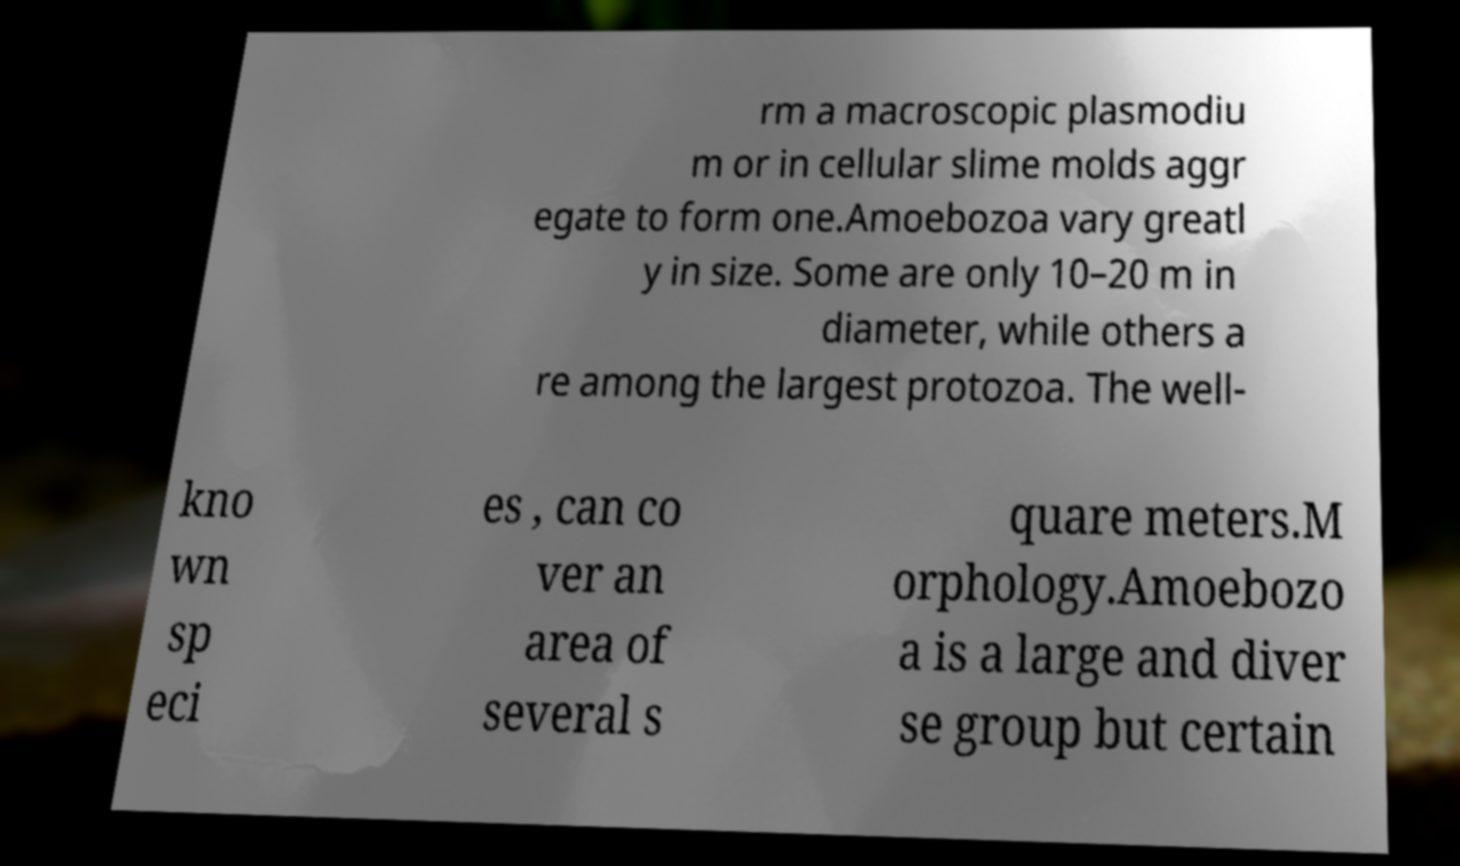For documentation purposes, I need the text within this image transcribed. Could you provide that? rm a macroscopic plasmodiu m or in cellular slime molds aggr egate to form one.Amoebozoa vary greatl y in size. Some are only 10–20 m in diameter, while others a re among the largest protozoa. The well- kno wn sp eci es , can co ver an area of several s quare meters.M orphology.Amoebozo a is a large and diver se group but certain 